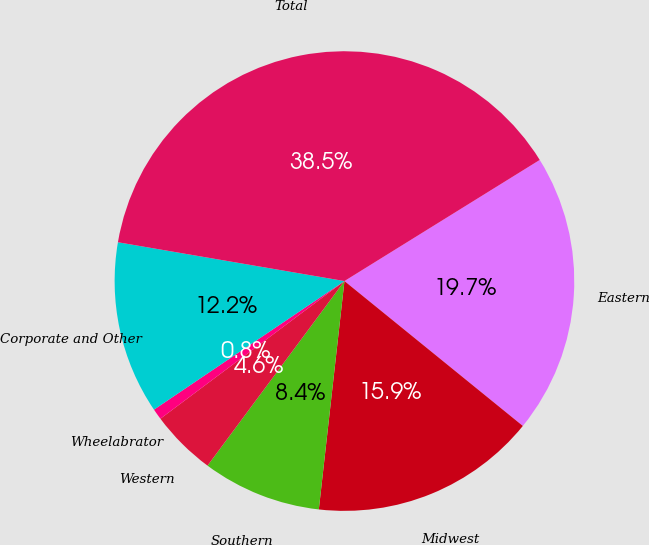<chart> <loc_0><loc_0><loc_500><loc_500><pie_chart><fcel>Eastern<fcel>Midwest<fcel>Southern<fcel>Western<fcel>Wheelabrator<fcel>Corporate and Other<fcel>Total<nl><fcel>19.69%<fcel>15.92%<fcel>8.38%<fcel>4.62%<fcel>0.77%<fcel>12.15%<fcel>38.46%<nl></chart> 